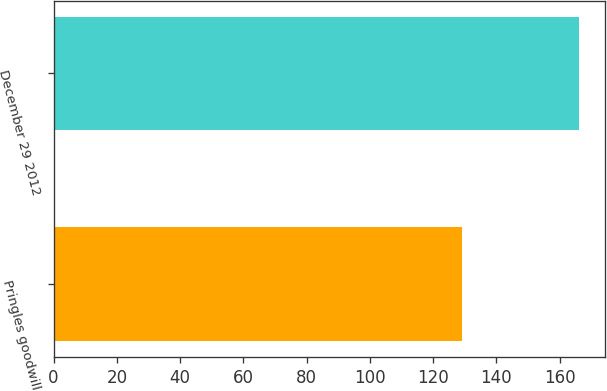<chart> <loc_0><loc_0><loc_500><loc_500><bar_chart><fcel>Pringles goodwill<fcel>December 29 2012<nl><fcel>129<fcel>166<nl></chart> 